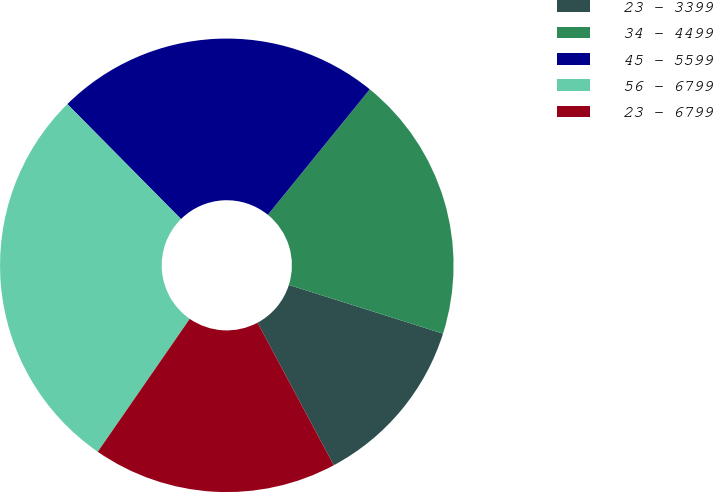Convert chart. <chart><loc_0><loc_0><loc_500><loc_500><pie_chart><fcel>23 - 3399<fcel>34 - 4499<fcel>45 - 5599<fcel>56 - 6799<fcel>23 - 6799<nl><fcel>12.31%<fcel>19.01%<fcel>23.27%<fcel>27.95%<fcel>17.45%<nl></chart> 